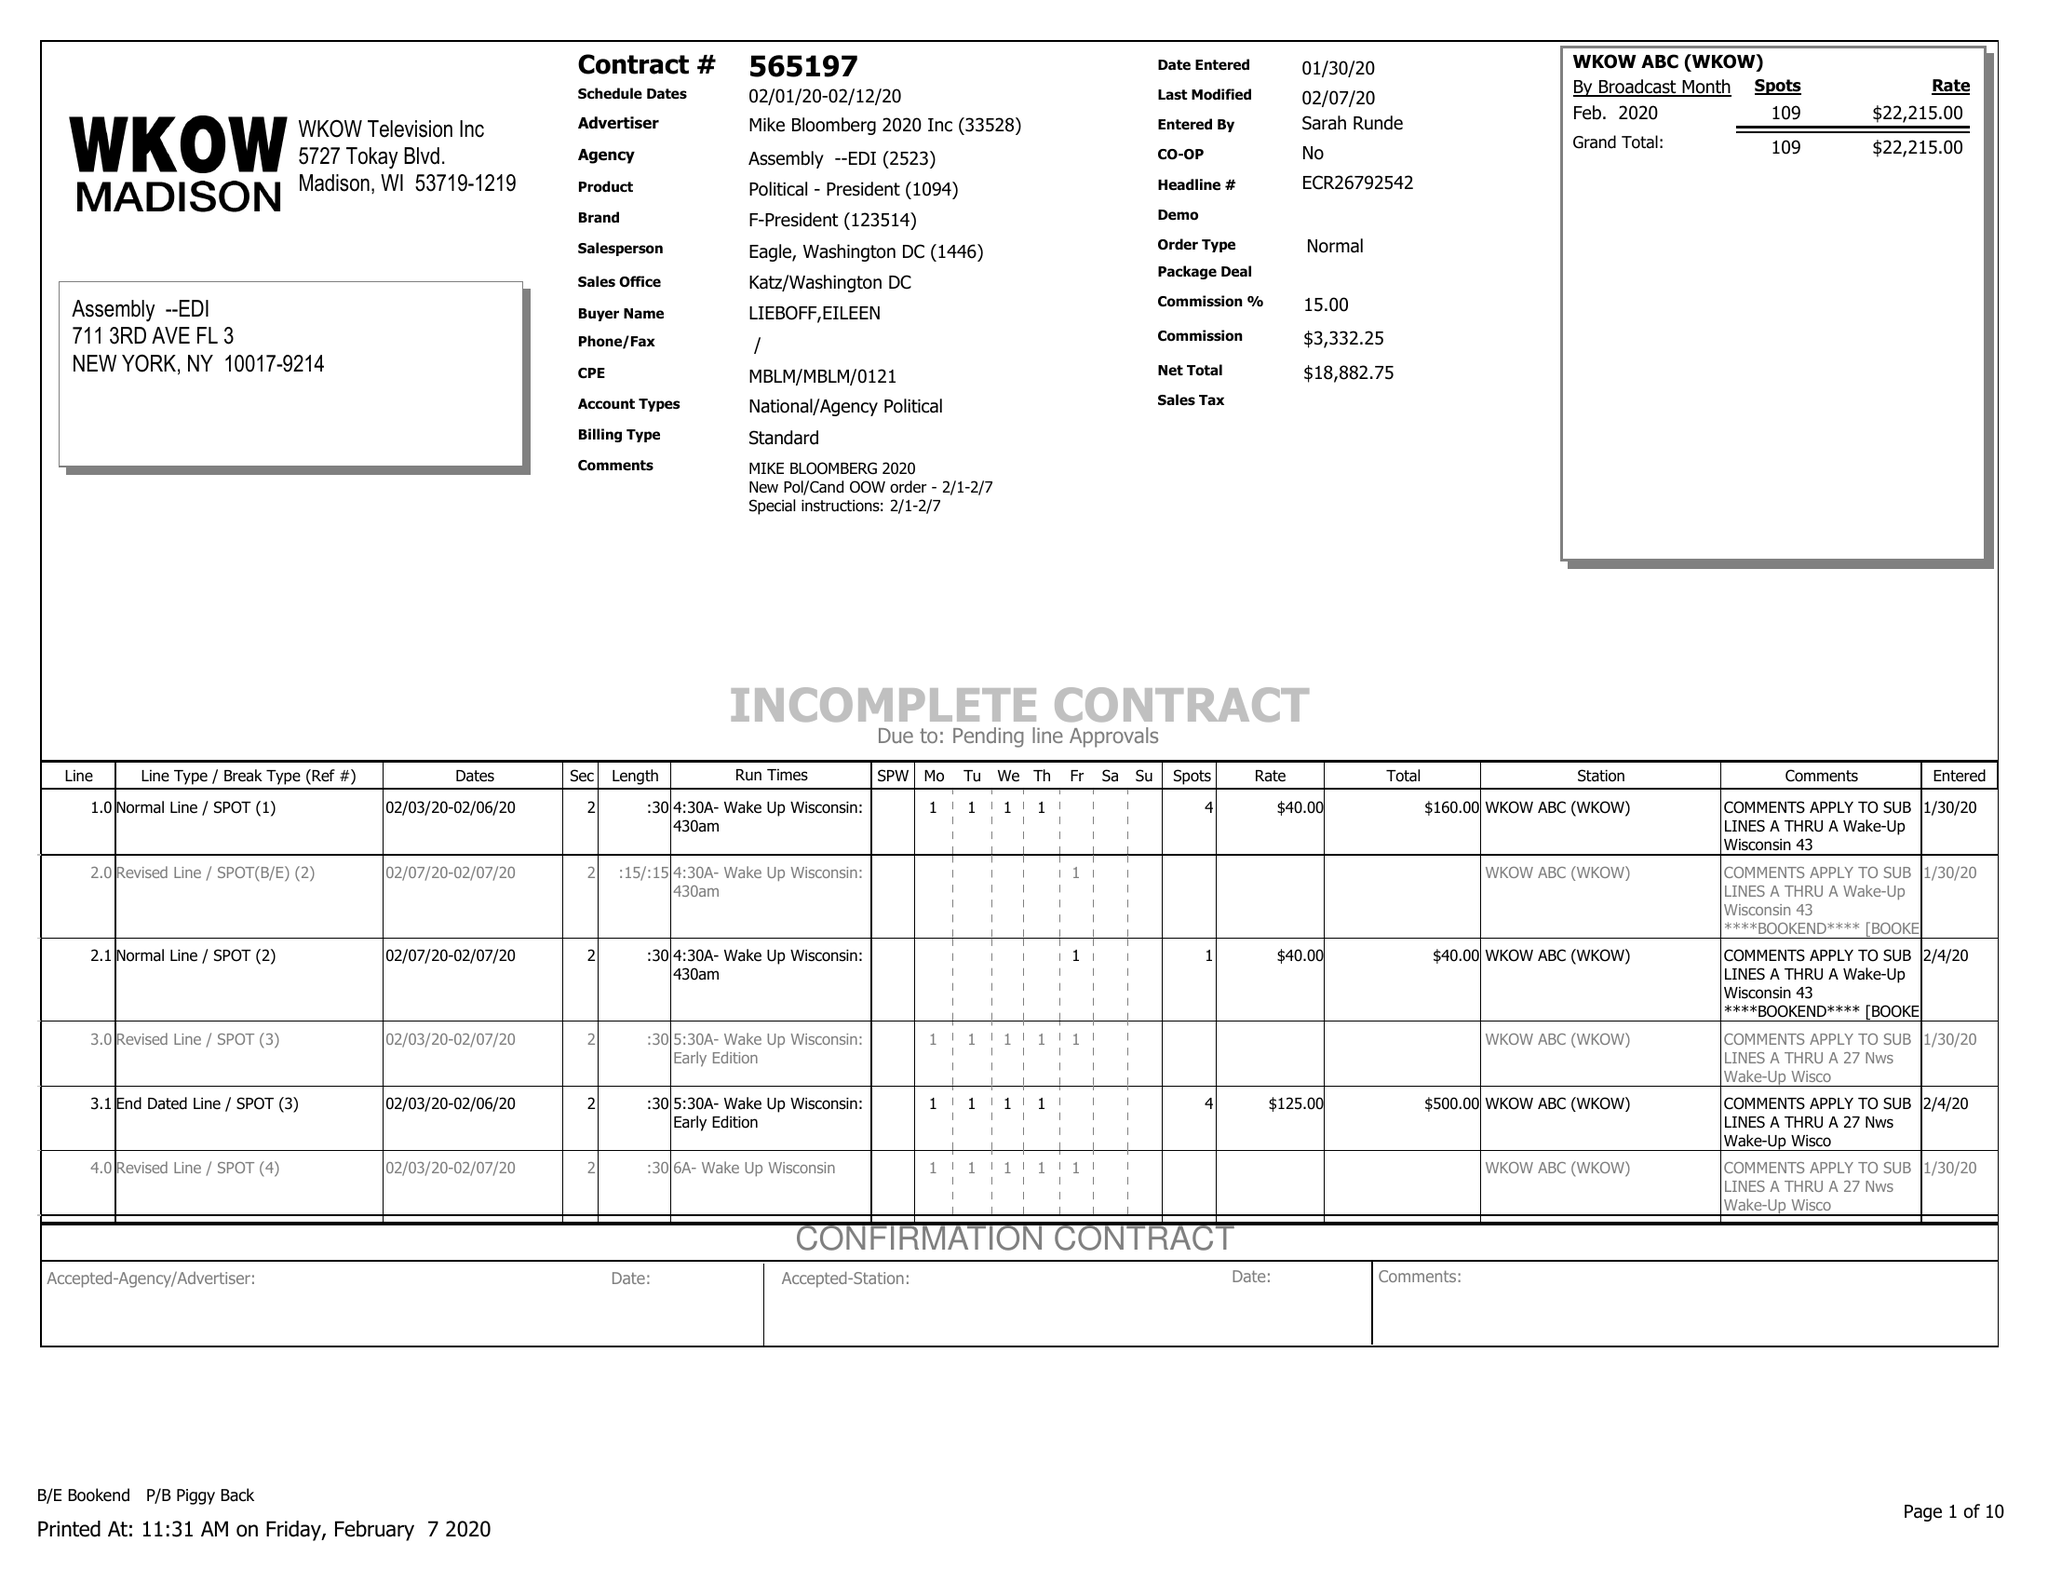What is the value for the contract_num?
Answer the question using a single word or phrase. 565197 